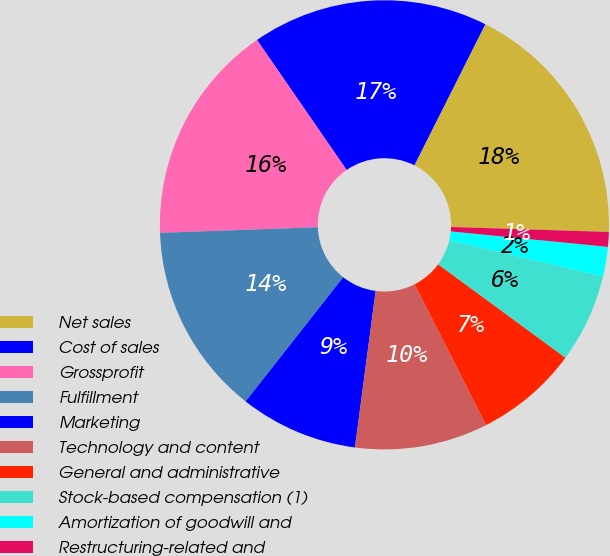<chart> <loc_0><loc_0><loc_500><loc_500><pie_chart><fcel>Net sales<fcel>Cost of sales<fcel>Grossprofit<fcel>Fulfillment<fcel>Marketing<fcel>Technology and content<fcel>General and administrative<fcel>Stock-based compensation (1)<fcel>Amortization of goodwill and<fcel>Restructuring-related and<nl><fcel>18.09%<fcel>17.02%<fcel>15.96%<fcel>13.83%<fcel>8.51%<fcel>9.57%<fcel>7.45%<fcel>6.38%<fcel>2.13%<fcel>1.06%<nl></chart> 